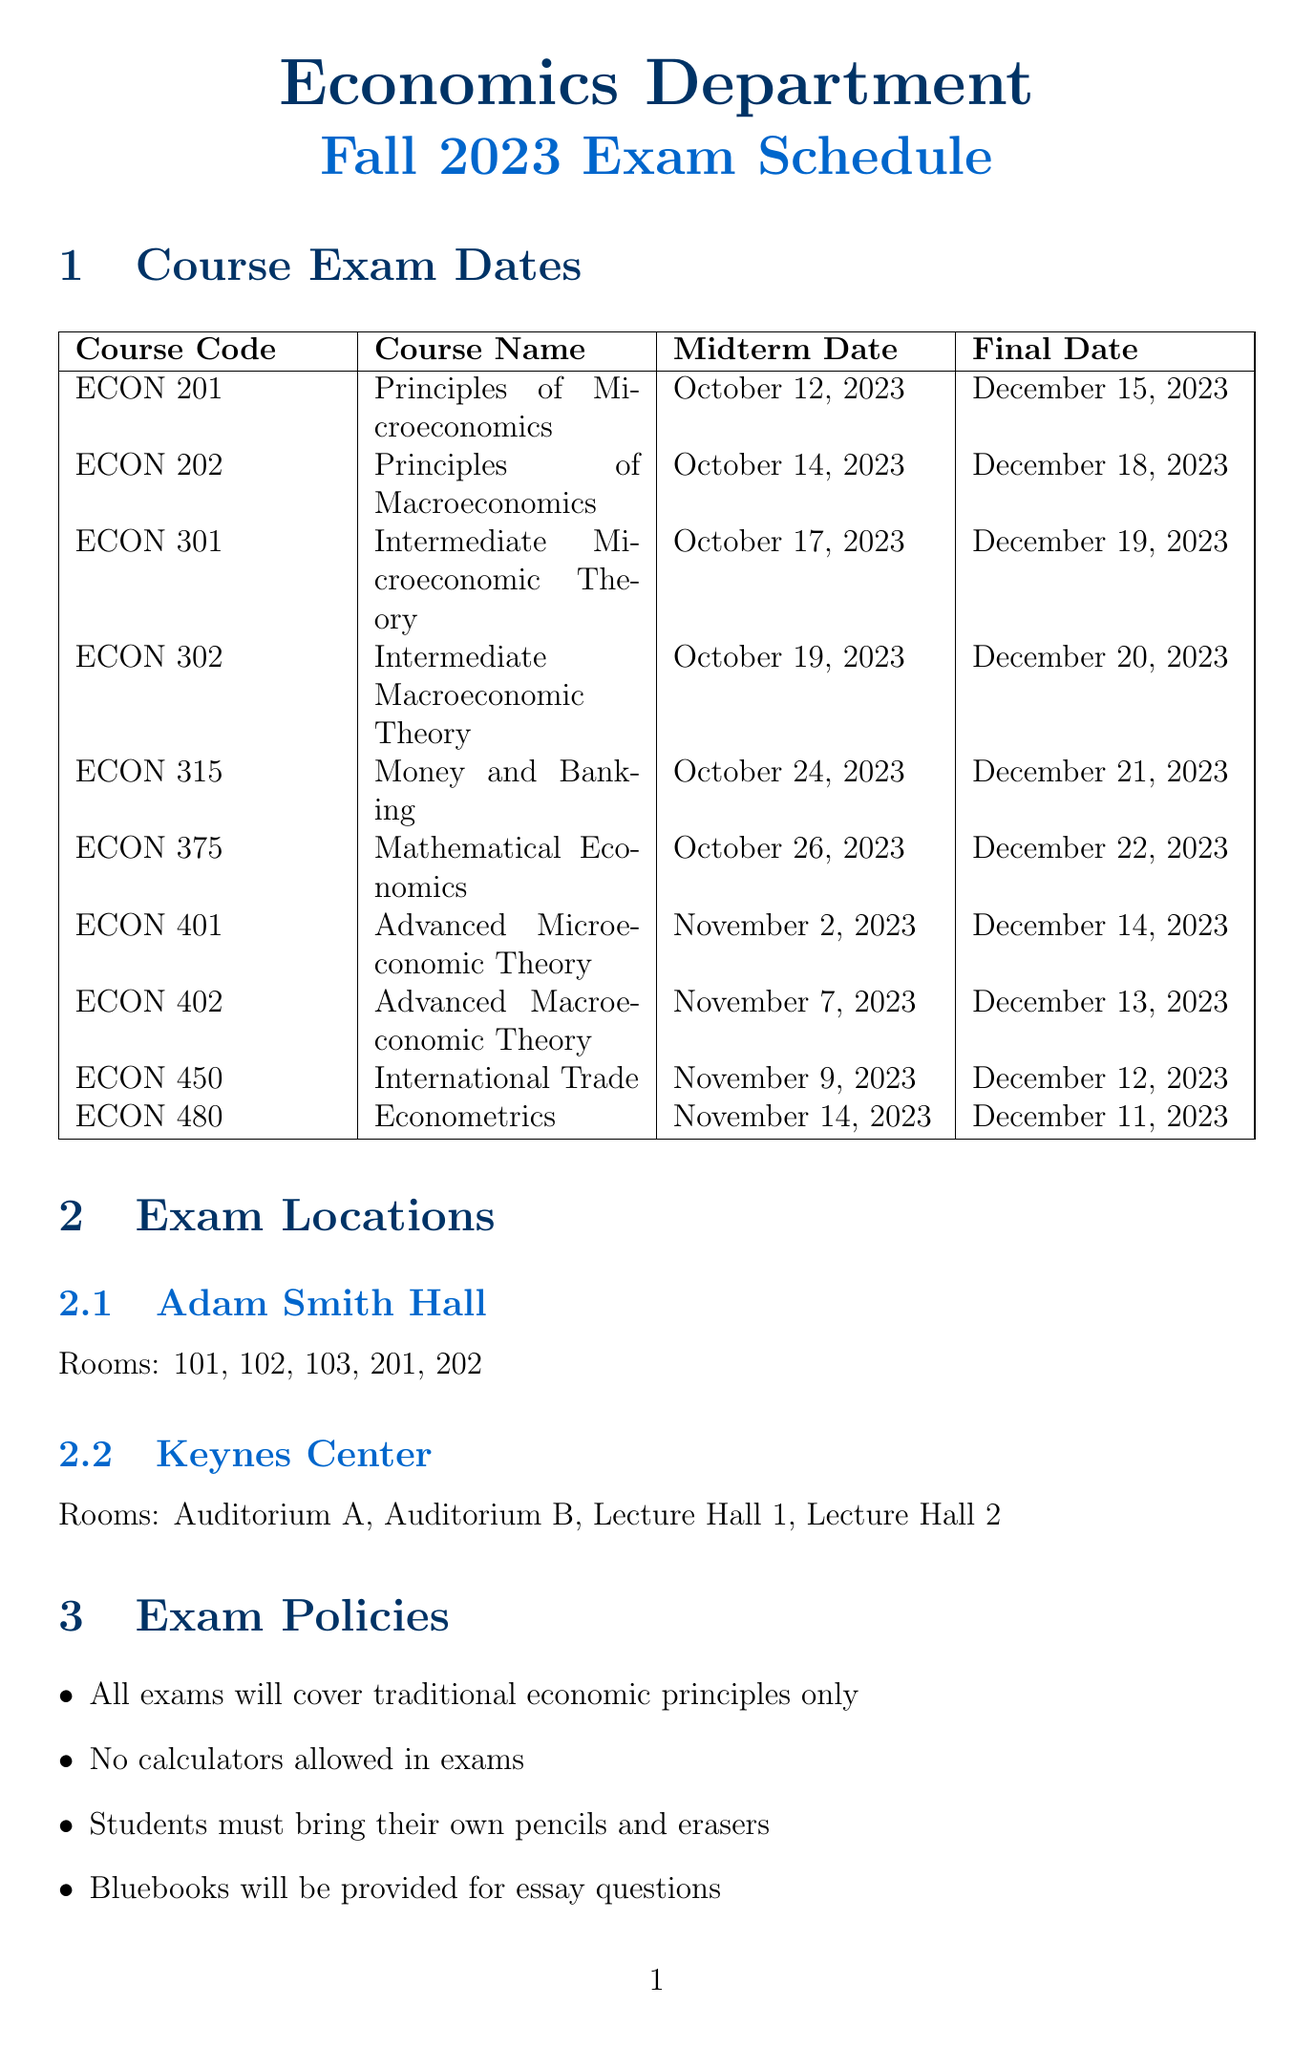What is the midterm date for ECON 201? The midterm date for ECON 201 is explicitly listed in the document under the midterm dates section.
Answer: October 12, 2023 What is the final exam date for ECON 302? The final exam date for ECON 302 can be found in the course exam dates table in the document.
Answer: December 20, 2023 Which building has rooms labeled as 101, 102, and 103? The document specifies the locations of the exam rooms, stating that these rooms are in Adam Smith Hall.
Answer: Adam Smith Hall How many days are there between the midterm and final exam for ECON 375? The document lists the midterm and final exam dates for ECON 375, which are on October 26, 2023, and December 22, 2023, respectively.
Answer: 57 days What is the policy regarding electronic devices during exams? The document includes a list of exam policies, mentioning restrictions on electronic devices clearly.
Answer: No electronic devices permitted during exams Which textbook is mentioned for Econometrics? The document lists study resources, including textbooks relevant to the courses, specifically for Econometrics.
Answer: 'Macroeconomics' by Olivier Blanchard How many courses have their midterm exams in November? By counting the midterm exam dates listed in the document for November, we can determine how many courses fall into this month.
Answer: 3 What is a resource available at the library for exam preparation? The document lists several study resources, indicating that economics department study guides can be accessed at the library.
Answer: Economics department study guides What is the last course’s final exam date? The final exam date for the last listed course in the document is found in the course exam dates table.
Answer: December 11, 2023 